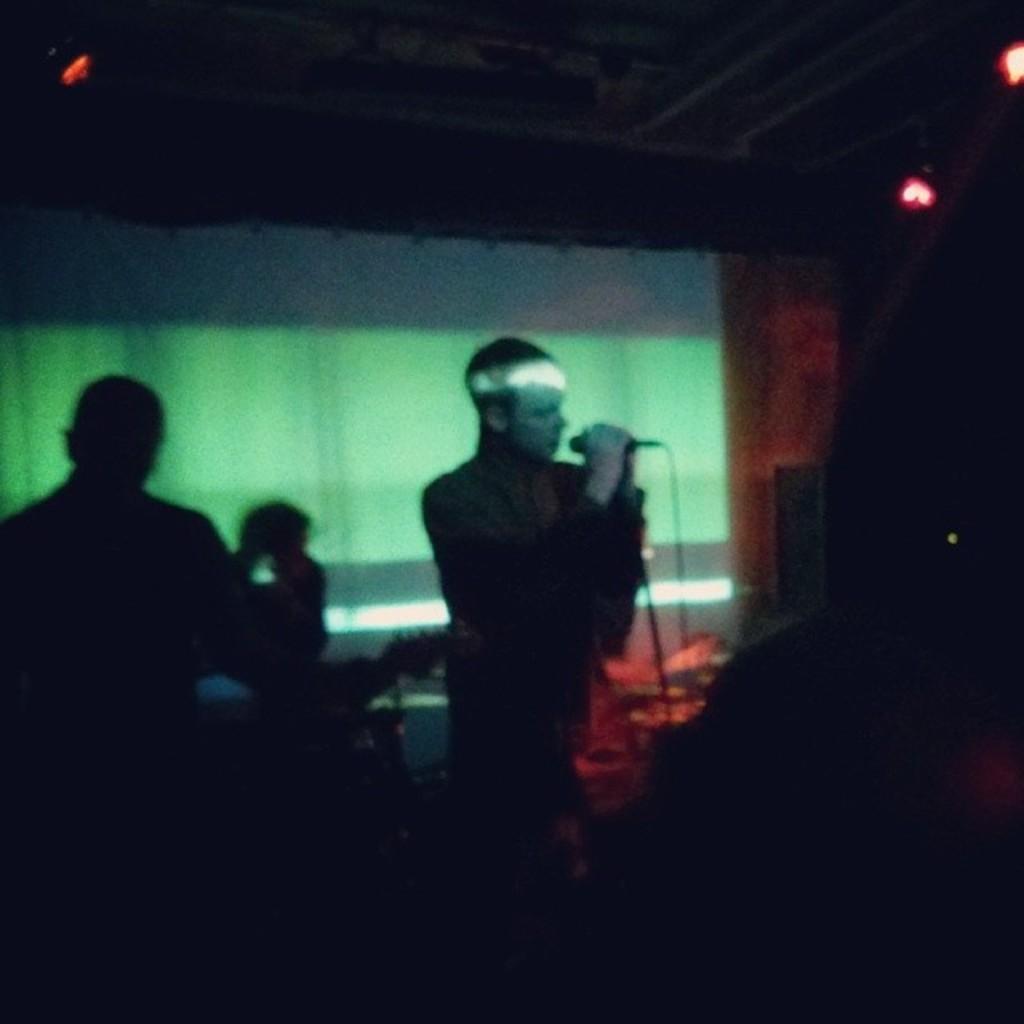How would you summarize this image in a sentence or two? The man in the middle of the picture is holding a microphone in his hand and I think he is singing the song on the microphone. On the left side, we see a man is standing. In the background, we see a white color sheet or a banner. In the background, it is black in color. This picture is clicked in the dark. This picture might be clicked in the musical concert. 